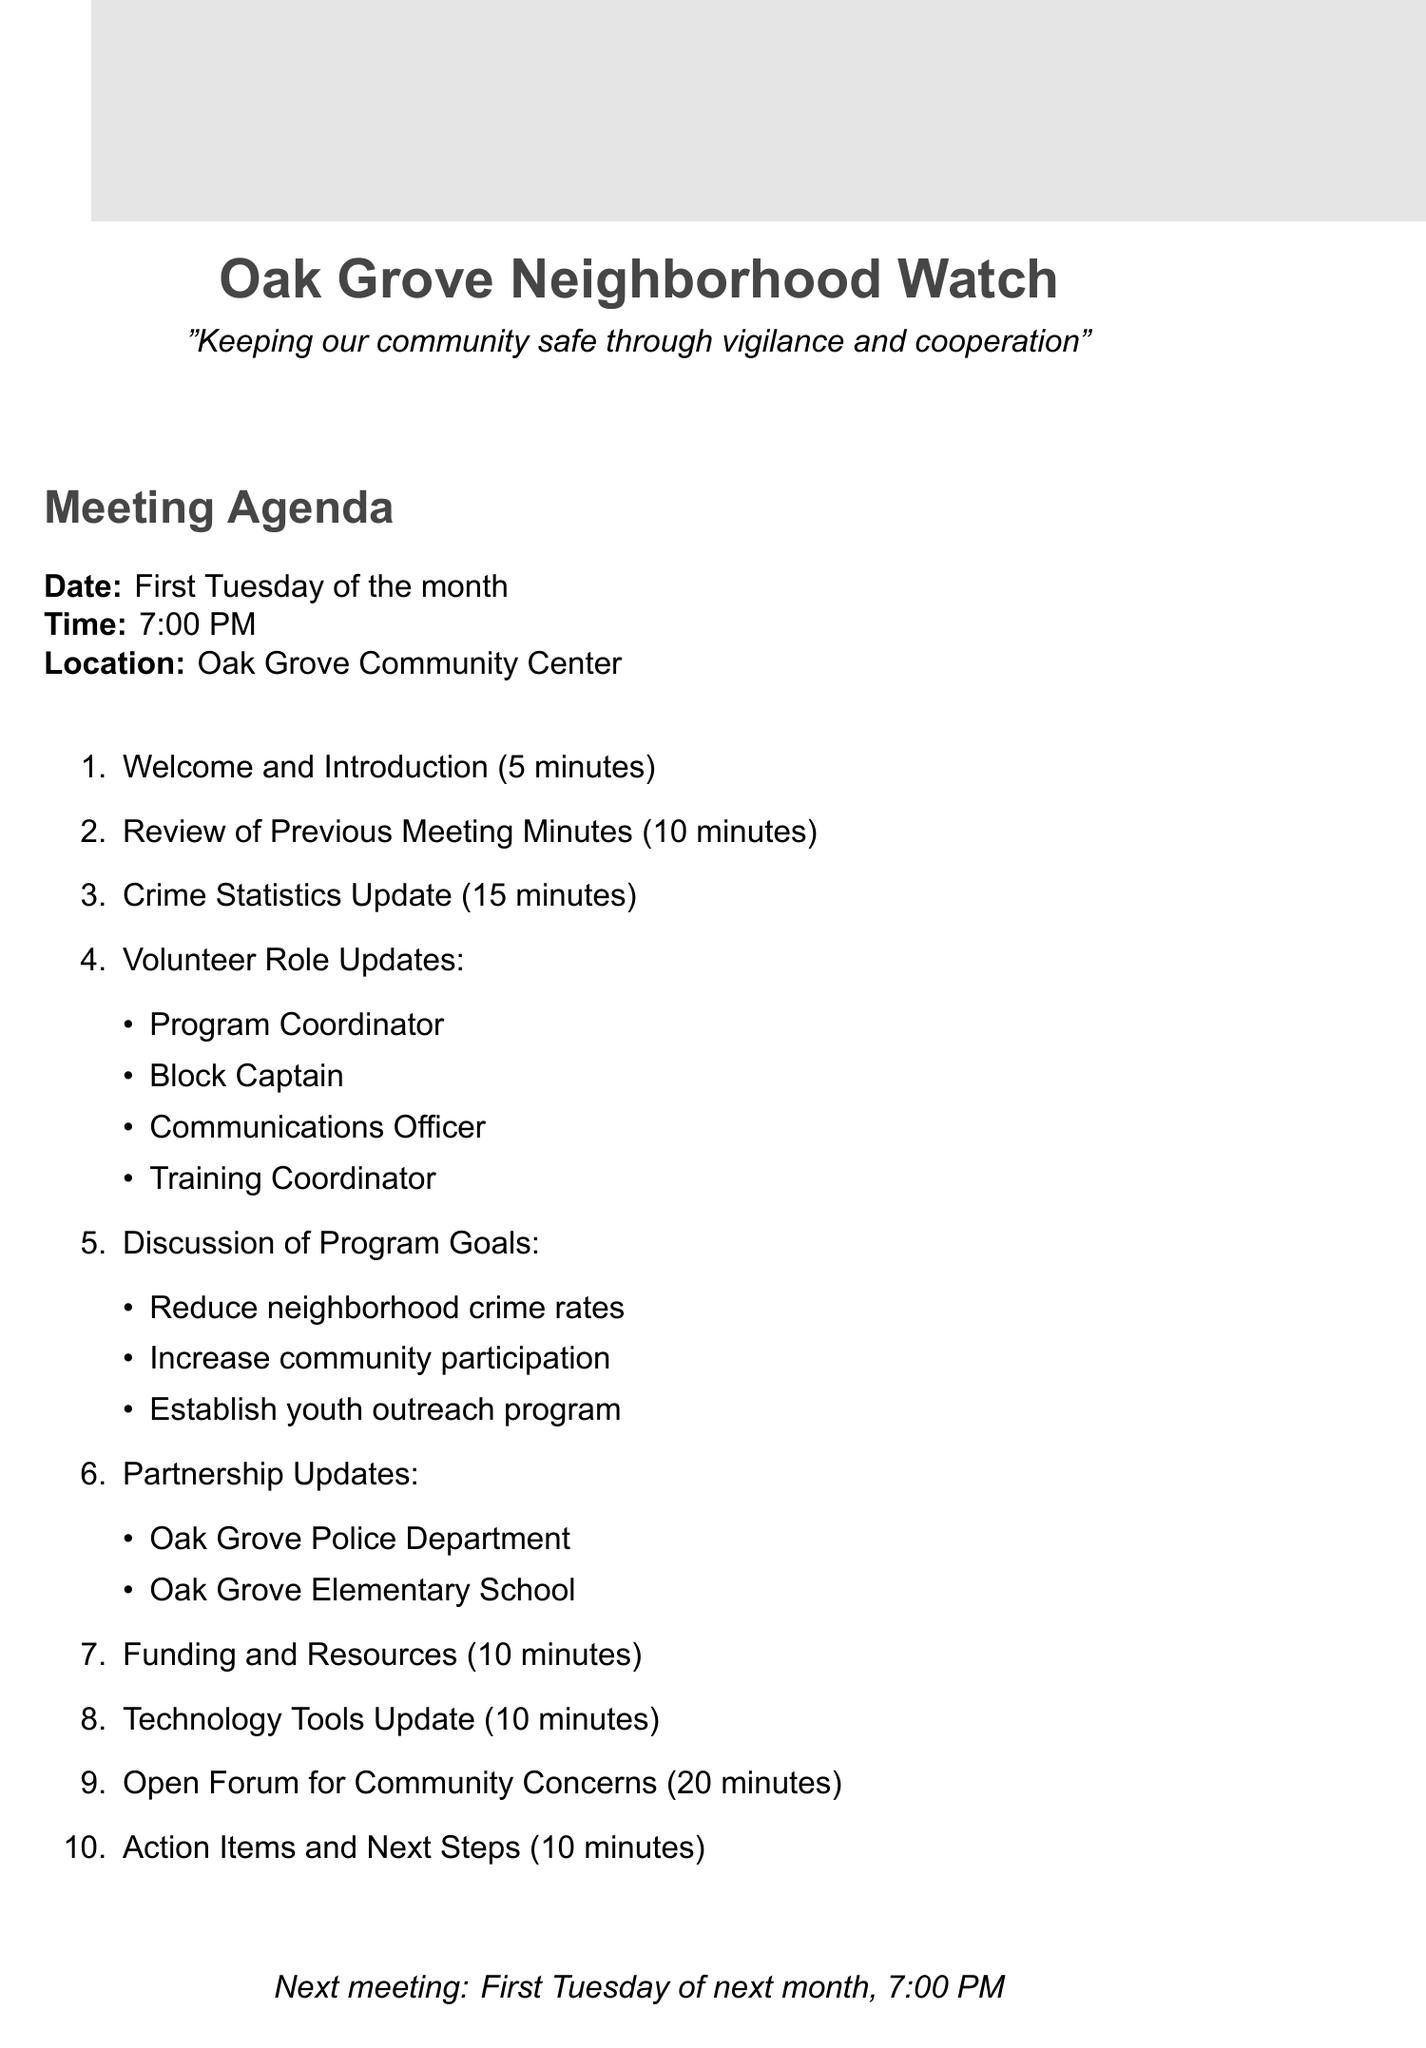what is the program name? The program name is clearly stated at the beginning of the document.
Answer: Oak Grove Neighborhood Watch what is the mission statement? The mission statement is included under the program name.
Answer: Keeping our community safe through vigilance and cooperation how often are the meetings held? The frequency of the meetings is specified in the meeting schedule section.
Answer: Monthly who is responsible for organizing the safety workshops? This role is outlined in the volunteer roles section under responsibilities.
Answer: Training Coordinator what day of the month do the meetings occur? The day of the month for meetings is specified in the meeting schedule section.
Answer: First Tuesday what is one of the program goals? The program goals are listed in a distinct section, providing various objectives.
Answer: Reduce neighborhood crime rates by 15% within the first year which partner is involved in the distribution of safety materials to students? This information can be found in the partnership opportunities section.
Answer: Oak Grove Elementary School how much is the optional household membership fee? The funding sources section indicates the membership fee amount.
Answer: $20/year what challenge is addressed with a Junior Neighborhood Watch program? The challenge and corresponding solution can be found in the challenges and solutions section.
Answer: Lack of youth engagement 